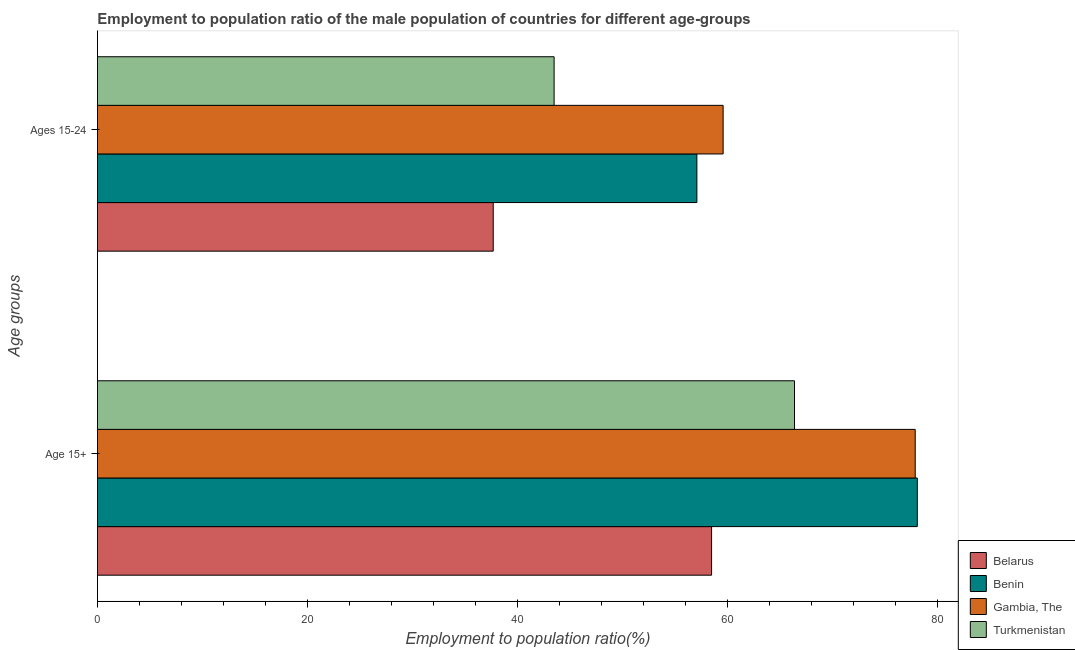How many different coloured bars are there?
Make the answer very short. 4. How many groups of bars are there?
Provide a short and direct response. 2. Are the number of bars per tick equal to the number of legend labels?
Offer a very short reply. Yes. What is the label of the 2nd group of bars from the top?
Ensure brevity in your answer.  Age 15+. What is the employment to population ratio(age 15+) in Benin?
Your response must be concise. 78.1. Across all countries, what is the maximum employment to population ratio(age 15-24)?
Your answer should be very brief. 59.6. Across all countries, what is the minimum employment to population ratio(age 15-24)?
Give a very brief answer. 37.7. In which country was the employment to population ratio(age 15+) maximum?
Ensure brevity in your answer.  Benin. In which country was the employment to population ratio(age 15+) minimum?
Keep it short and to the point. Belarus. What is the total employment to population ratio(age 15-24) in the graph?
Offer a terse response. 197.9. What is the difference between the employment to population ratio(age 15+) in Gambia, The and that in Benin?
Your answer should be compact. -0.2. What is the difference between the employment to population ratio(age 15-24) in Benin and the employment to population ratio(age 15+) in Turkmenistan?
Offer a very short reply. -9.3. What is the average employment to population ratio(age 15+) per country?
Offer a terse response. 70.23. What is the difference between the employment to population ratio(age 15+) and employment to population ratio(age 15-24) in Benin?
Offer a very short reply. 21. What is the ratio of the employment to population ratio(age 15-24) in Benin to that in Belarus?
Offer a very short reply. 1.51. What does the 4th bar from the top in Ages 15-24 represents?
Provide a short and direct response. Belarus. What does the 3rd bar from the bottom in Age 15+ represents?
Your response must be concise. Gambia, The. How many bars are there?
Offer a terse response. 8. How many countries are there in the graph?
Your answer should be compact. 4. Does the graph contain any zero values?
Offer a terse response. No. Does the graph contain grids?
Provide a succinct answer. No. Where does the legend appear in the graph?
Ensure brevity in your answer.  Bottom right. How many legend labels are there?
Give a very brief answer. 4. How are the legend labels stacked?
Offer a terse response. Vertical. What is the title of the graph?
Your answer should be very brief. Employment to population ratio of the male population of countries for different age-groups. Does "Kosovo" appear as one of the legend labels in the graph?
Make the answer very short. No. What is the label or title of the X-axis?
Make the answer very short. Employment to population ratio(%). What is the label or title of the Y-axis?
Make the answer very short. Age groups. What is the Employment to population ratio(%) in Belarus in Age 15+?
Your response must be concise. 58.5. What is the Employment to population ratio(%) in Benin in Age 15+?
Provide a short and direct response. 78.1. What is the Employment to population ratio(%) in Gambia, The in Age 15+?
Keep it short and to the point. 77.9. What is the Employment to population ratio(%) of Turkmenistan in Age 15+?
Offer a terse response. 66.4. What is the Employment to population ratio(%) of Belarus in Ages 15-24?
Offer a very short reply. 37.7. What is the Employment to population ratio(%) in Benin in Ages 15-24?
Provide a short and direct response. 57.1. What is the Employment to population ratio(%) of Gambia, The in Ages 15-24?
Make the answer very short. 59.6. What is the Employment to population ratio(%) in Turkmenistan in Ages 15-24?
Your answer should be very brief. 43.5. Across all Age groups, what is the maximum Employment to population ratio(%) in Belarus?
Your response must be concise. 58.5. Across all Age groups, what is the maximum Employment to population ratio(%) of Benin?
Keep it short and to the point. 78.1. Across all Age groups, what is the maximum Employment to population ratio(%) of Gambia, The?
Provide a succinct answer. 77.9. Across all Age groups, what is the maximum Employment to population ratio(%) of Turkmenistan?
Offer a very short reply. 66.4. Across all Age groups, what is the minimum Employment to population ratio(%) in Belarus?
Ensure brevity in your answer.  37.7. Across all Age groups, what is the minimum Employment to population ratio(%) in Benin?
Make the answer very short. 57.1. Across all Age groups, what is the minimum Employment to population ratio(%) of Gambia, The?
Offer a terse response. 59.6. Across all Age groups, what is the minimum Employment to population ratio(%) of Turkmenistan?
Provide a succinct answer. 43.5. What is the total Employment to population ratio(%) in Belarus in the graph?
Your answer should be compact. 96.2. What is the total Employment to population ratio(%) in Benin in the graph?
Ensure brevity in your answer.  135.2. What is the total Employment to population ratio(%) of Gambia, The in the graph?
Give a very brief answer. 137.5. What is the total Employment to population ratio(%) of Turkmenistan in the graph?
Provide a short and direct response. 109.9. What is the difference between the Employment to population ratio(%) of Belarus in Age 15+ and that in Ages 15-24?
Offer a very short reply. 20.8. What is the difference between the Employment to population ratio(%) in Benin in Age 15+ and that in Ages 15-24?
Your answer should be compact. 21. What is the difference between the Employment to population ratio(%) in Gambia, The in Age 15+ and that in Ages 15-24?
Offer a terse response. 18.3. What is the difference between the Employment to population ratio(%) in Turkmenistan in Age 15+ and that in Ages 15-24?
Provide a succinct answer. 22.9. What is the difference between the Employment to population ratio(%) in Belarus in Age 15+ and the Employment to population ratio(%) in Benin in Ages 15-24?
Give a very brief answer. 1.4. What is the difference between the Employment to population ratio(%) of Belarus in Age 15+ and the Employment to population ratio(%) of Turkmenistan in Ages 15-24?
Your response must be concise. 15. What is the difference between the Employment to population ratio(%) of Benin in Age 15+ and the Employment to population ratio(%) of Turkmenistan in Ages 15-24?
Your answer should be compact. 34.6. What is the difference between the Employment to population ratio(%) of Gambia, The in Age 15+ and the Employment to population ratio(%) of Turkmenistan in Ages 15-24?
Keep it short and to the point. 34.4. What is the average Employment to population ratio(%) in Belarus per Age groups?
Ensure brevity in your answer.  48.1. What is the average Employment to population ratio(%) of Benin per Age groups?
Your answer should be very brief. 67.6. What is the average Employment to population ratio(%) of Gambia, The per Age groups?
Keep it short and to the point. 68.75. What is the average Employment to population ratio(%) in Turkmenistan per Age groups?
Give a very brief answer. 54.95. What is the difference between the Employment to population ratio(%) in Belarus and Employment to population ratio(%) in Benin in Age 15+?
Make the answer very short. -19.6. What is the difference between the Employment to population ratio(%) in Belarus and Employment to population ratio(%) in Gambia, The in Age 15+?
Offer a very short reply. -19.4. What is the difference between the Employment to population ratio(%) in Benin and Employment to population ratio(%) in Turkmenistan in Age 15+?
Offer a very short reply. 11.7. What is the difference between the Employment to population ratio(%) in Gambia, The and Employment to population ratio(%) in Turkmenistan in Age 15+?
Provide a succinct answer. 11.5. What is the difference between the Employment to population ratio(%) of Belarus and Employment to population ratio(%) of Benin in Ages 15-24?
Offer a terse response. -19.4. What is the difference between the Employment to population ratio(%) in Belarus and Employment to population ratio(%) in Gambia, The in Ages 15-24?
Give a very brief answer. -21.9. What is the difference between the Employment to population ratio(%) of Benin and Employment to population ratio(%) of Gambia, The in Ages 15-24?
Give a very brief answer. -2.5. What is the difference between the Employment to population ratio(%) of Benin and Employment to population ratio(%) of Turkmenistan in Ages 15-24?
Give a very brief answer. 13.6. What is the ratio of the Employment to population ratio(%) in Belarus in Age 15+ to that in Ages 15-24?
Your answer should be very brief. 1.55. What is the ratio of the Employment to population ratio(%) of Benin in Age 15+ to that in Ages 15-24?
Provide a succinct answer. 1.37. What is the ratio of the Employment to population ratio(%) in Gambia, The in Age 15+ to that in Ages 15-24?
Give a very brief answer. 1.31. What is the ratio of the Employment to population ratio(%) in Turkmenistan in Age 15+ to that in Ages 15-24?
Your answer should be compact. 1.53. What is the difference between the highest and the second highest Employment to population ratio(%) of Belarus?
Your answer should be very brief. 20.8. What is the difference between the highest and the second highest Employment to population ratio(%) in Benin?
Provide a succinct answer. 21. What is the difference between the highest and the second highest Employment to population ratio(%) in Gambia, The?
Give a very brief answer. 18.3. What is the difference between the highest and the second highest Employment to population ratio(%) in Turkmenistan?
Give a very brief answer. 22.9. What is the difference between the highest and the lowest Employment to population ratio(%) of Belarus?
Offer a very short reply. 20.8. What is the difference between the highest and the lowest Employment to population ratio(%) in Benin?
Your answer should be compact. 21. What is the difference between the highest and the lowest Employment to population ratio(%) of Gambia, The?
Offer a terse response. 18.3. What is the difference between the highest and the lowest Employment to population ratio(%) in Turkmenistan?
Offer a very short reply. 22.9. 